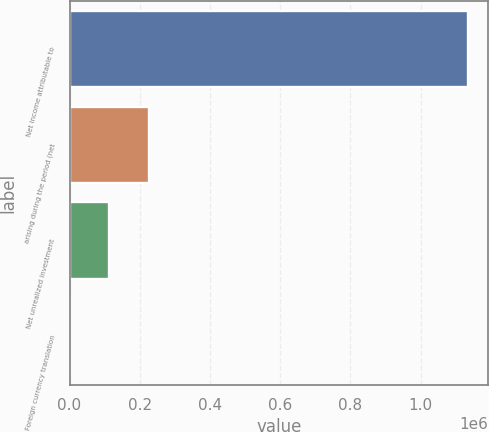Convert chart. <chart><loc_0><loc_0><loc_500><loc_500><bar_chart><fcel>Net income attributable to<fcel>arising during the period (net<fcel>Net unrealized investment<fcel>Foreign currency translation<nl><fcel>1.13485e+06<fcel>226994<fcel>113512<fcel>30<nl></chart> 